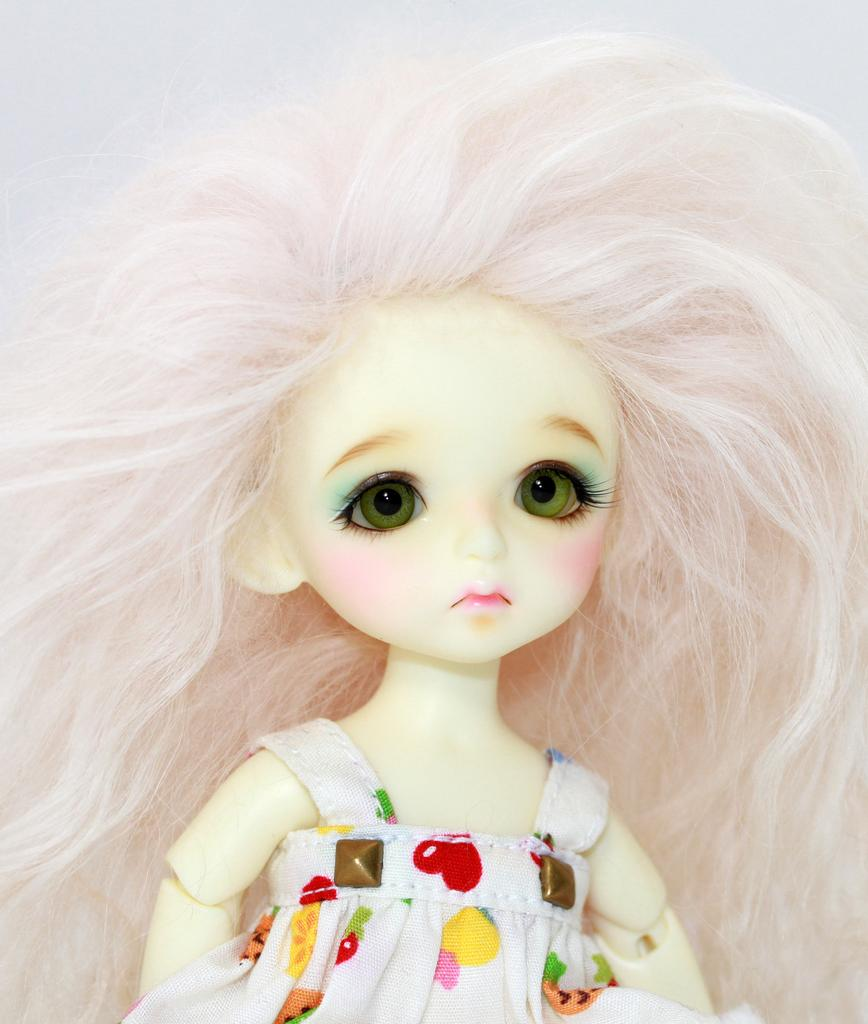What is the main subject of the image? There is a doll in the image. What can be observed about the doll's appearance? The doll is wearing clothes. What color is the background of the image? The background of the image is white. Can you see any cabbage growing in the background of the image? There is no cabbage present in the image, as the background is white and does not depict any vegetation. 